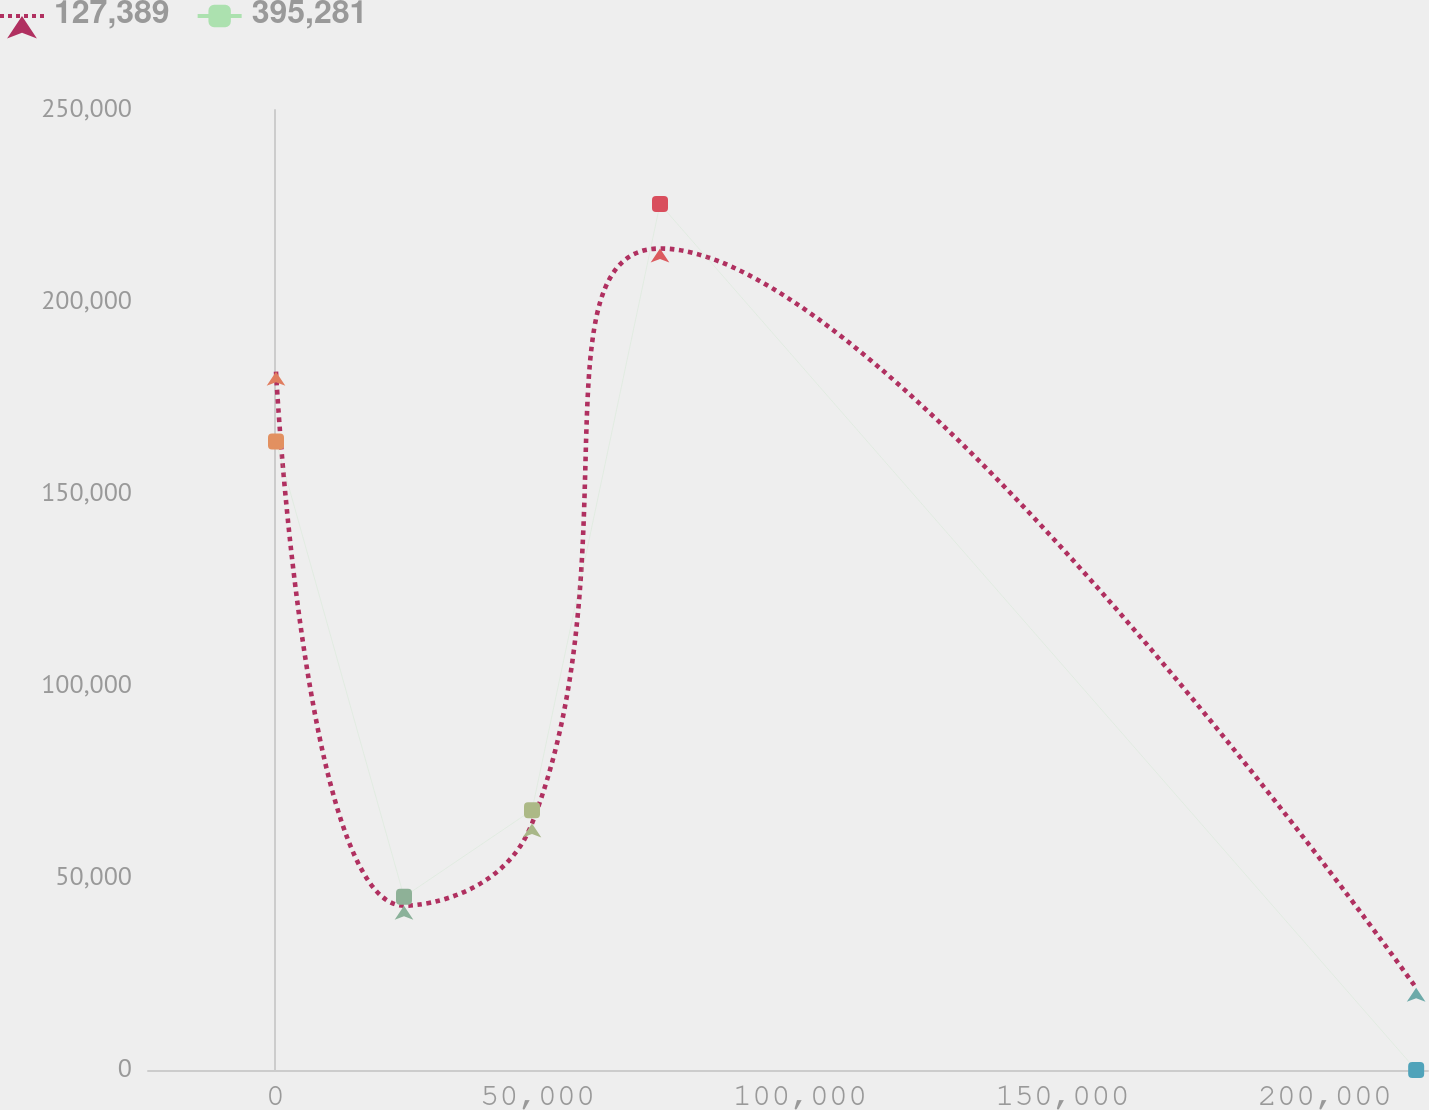<chart> <loc_0><loc_0><loc_500><loc_500><line_chart><ecel><fcel>127,389<fcel>395,281<nl><fcel>137.02<fcel>181848<fcel>163681<nl><fcel>24528.4<fcel>42789<fcel>45103.8<nl><fcel>48919.8<fcel>64182.6<fcel>67655.5<nl><fcel>73311.2<fcel>213937<fcel>225517<nl><fcel>217405<fcel>21395.5<fcel>0.57<nl><fcel>244051<fcel>1.96<fcel>22552.2<nl></chart> 